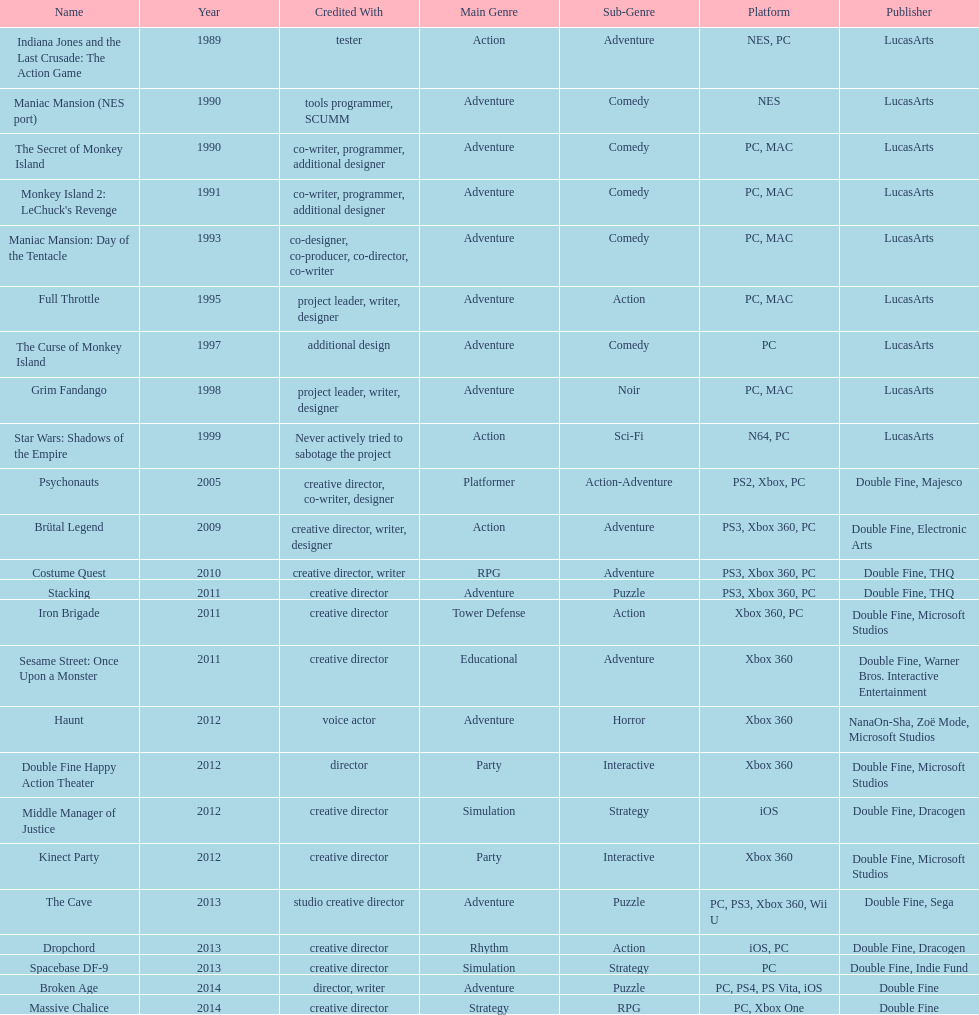How many games were credited with a creative director? 11. 